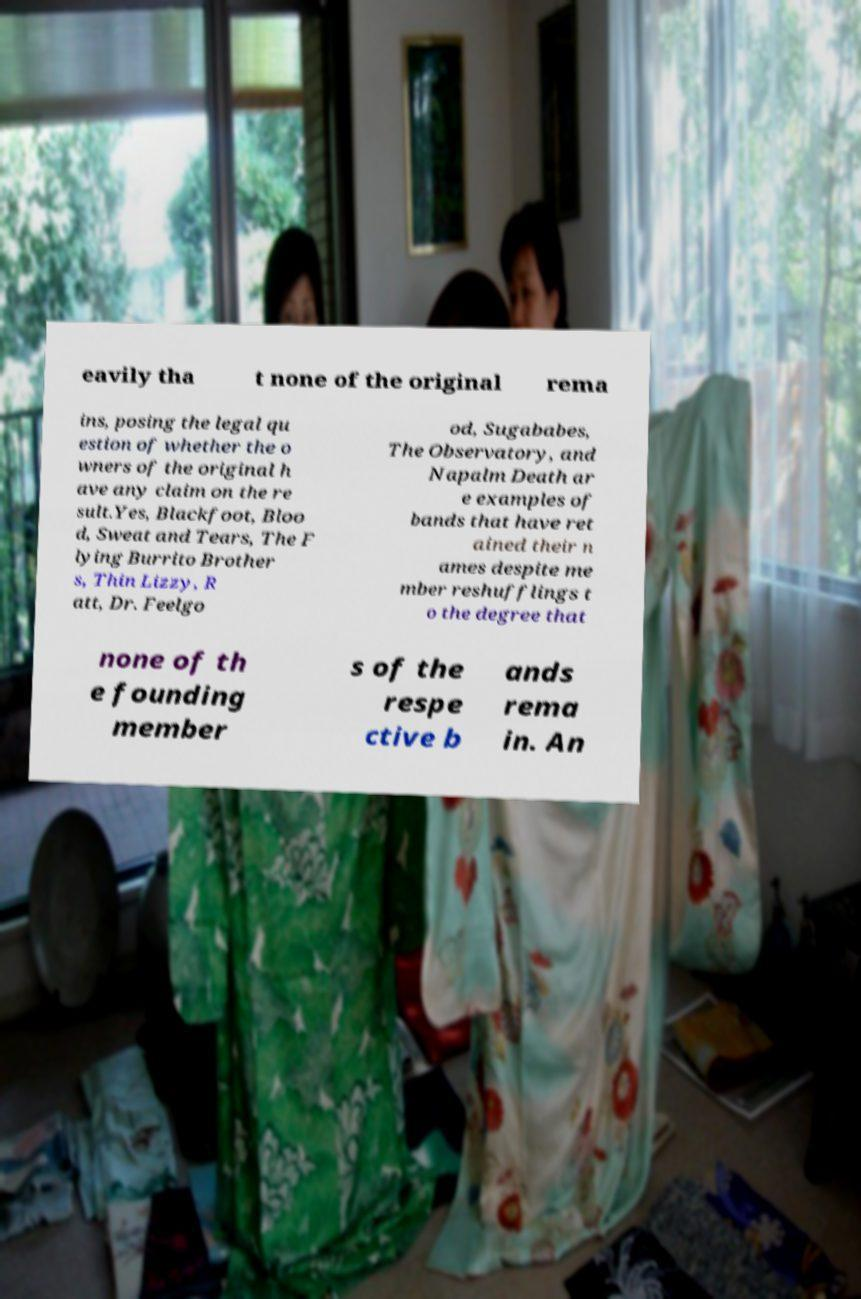Can you accurately transcribe the text from the provided image for me? eavily tha t none of the original rema ins, posing the legal qu estion of whether the o wners of the original h ave any claim on the re sult.Yes, Blackfoot, Bloo d, Sweat and Tears, The F lying Burrito Brother s, Thin Lizzy, R att, Dr. Feelgo od, Sugababes, The Observatory, and Napalm Death ar e examples of bands that have ret ained their n ames despite me mber reshufflings t o the degree that none of th e founding member s of the respe ctive b ands rema in. An 